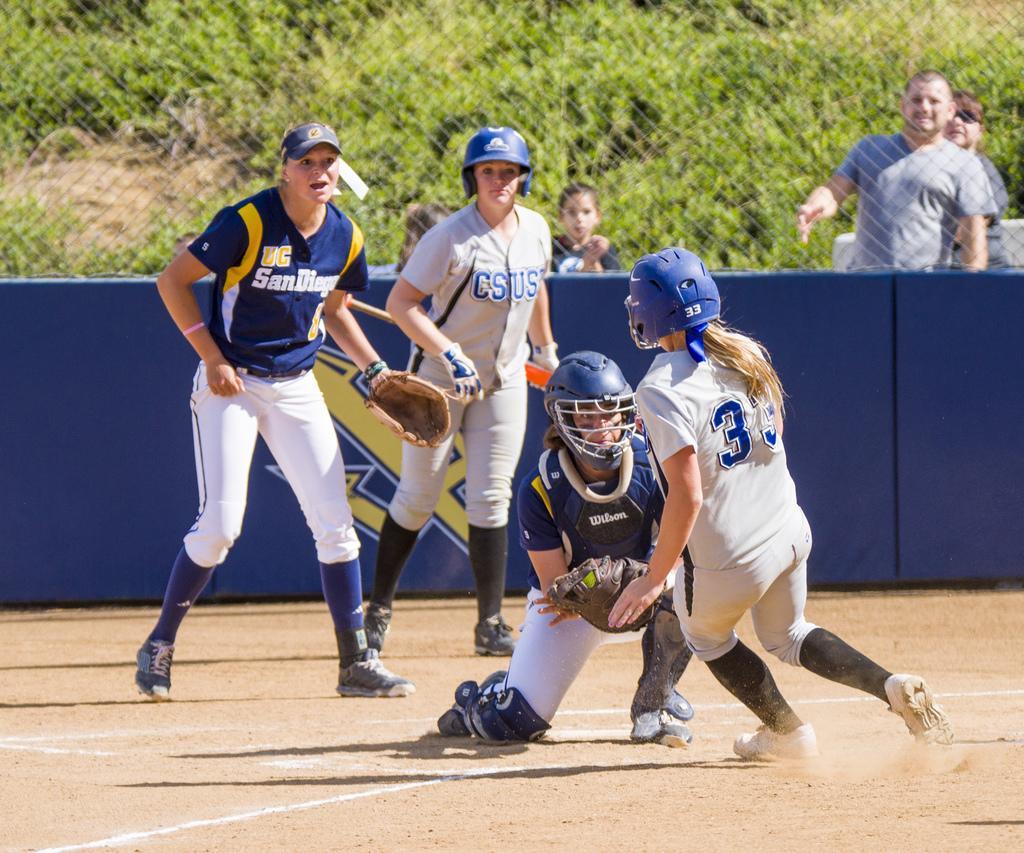Can you describe this image briefly? There are four players are in the ground as we can see at the bottom of this image. There is a fencing in the background. There are some other persons watching the game outside from this fencing. It seems like there are some trees in the background. 